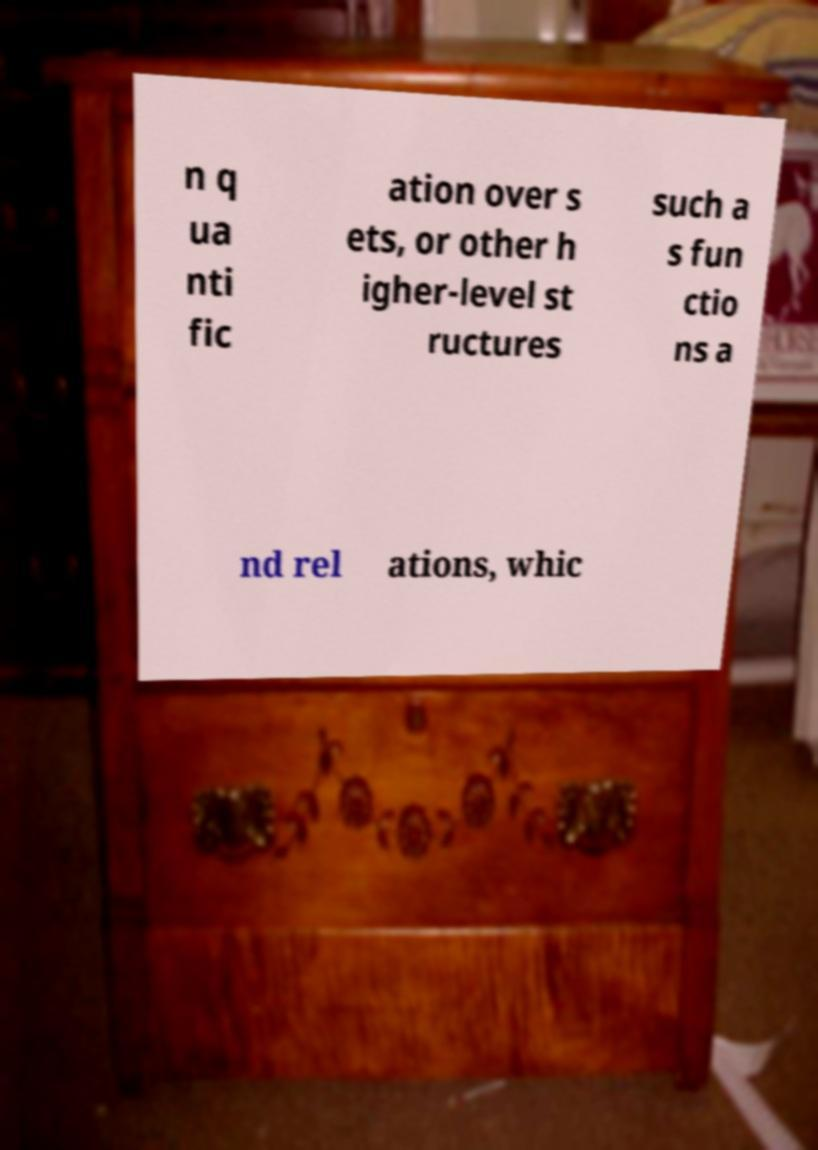Could you extract and type out the text from this image? n q ua nti fic ation over s ets, or other h igher-level st ructures such a s fun ctio ns a nd rel ations, whic 